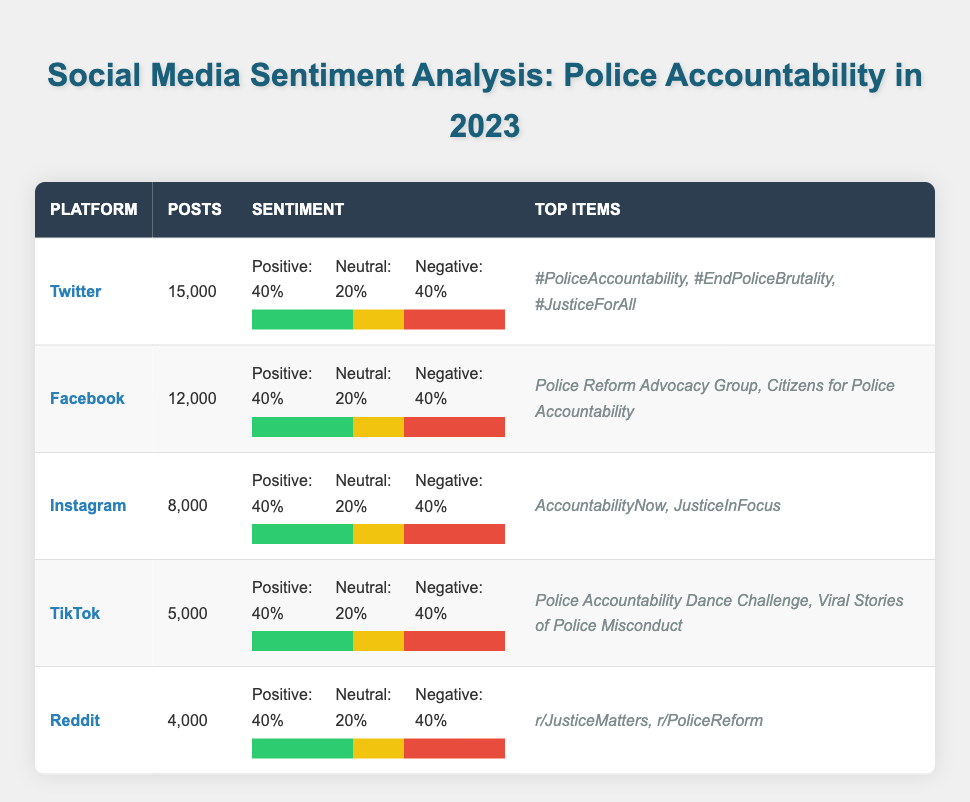What is the total number of posts across all platforms? To find the total number of posts, we add the posts from each platform: 15,000 (Twitter) + 12,000 (Facebook) + 8,000 (Instagram) + 5,000 (TikTok) + 4,000 (Reddit) = 44,000.
Answer: 44,000 What percentage of posts on Facebook have negative sentiment? The number of negative sentiment posts on Facebook is 4,800. The total posts on Facebook are 12,000. The formula for percentage is (negative posts / total posts) * 100. Thus, (4,800 / 12,000) * 100 = 40%.
Answer: 40% Which social media platform has the highest number of posts? We compare the total posts for each platform: Twitter - 15,000, Facebook - 12,000, Instagram - 8,000, TikTok - 5,000, and Reddit - 4,000. The highest is Twitter with 15,000 posts.
Answer: Twitter Is the positive sentiment percentage across all platforms the same? The positive sentiment percentages for all platforms are identical: 40% for Twitter, Facebook, Instagram, TikTok, and Reddit. Therefore, yes, they are the same.
Answer: Yes What is the difference in the number of negative sentiment posts between Instagram and Reddit? Negative sentiment posts for Instagram are 3,200 and for Reddit are 1,600. To find the difference, we subtract Reddit's negative posts from Instagram's: 3,200 - 1,600 = 1,600.
Answer: 1,600 Which platform has the least amount of positive sentiment posts? Looking at the positive sentiment posts: Twitter - 6,000, Facebook - 4,800, Instagram - 3,200, TikTok - 2,000, Reddit - 1,600. The platform with the least positive sentiment posts is Reddit with 1,600 posts.
Answer: Reddit What are the top hashtags mentioned on Twitter? The table shows that the top hashtags for Twitter are #PoliceAccountability, #EndPoliceBrutality, and #JusticeForAll.
Answer: #PoliceAccountability, #EndPoliceBrutality, #JusticeForAll Calculate the average number of posts for all platforms. We sum the number of posts: 15,000 (Twitter) + 12,000 (Facebook) + 8,000 (Instagram) + 5,000 (TikTok) + 4,000 (Reddit) = 44,000. There are 5 platforms, so we divide: 44,000 / 5 = 8,800.
Answer: 8,800 Which platform has the highest negative sentiment percentage? All platforms have the same negative sentiment percentage of 40%. Thus, there is no single platform with the highest negative sentiment percentage.
Answer: None 